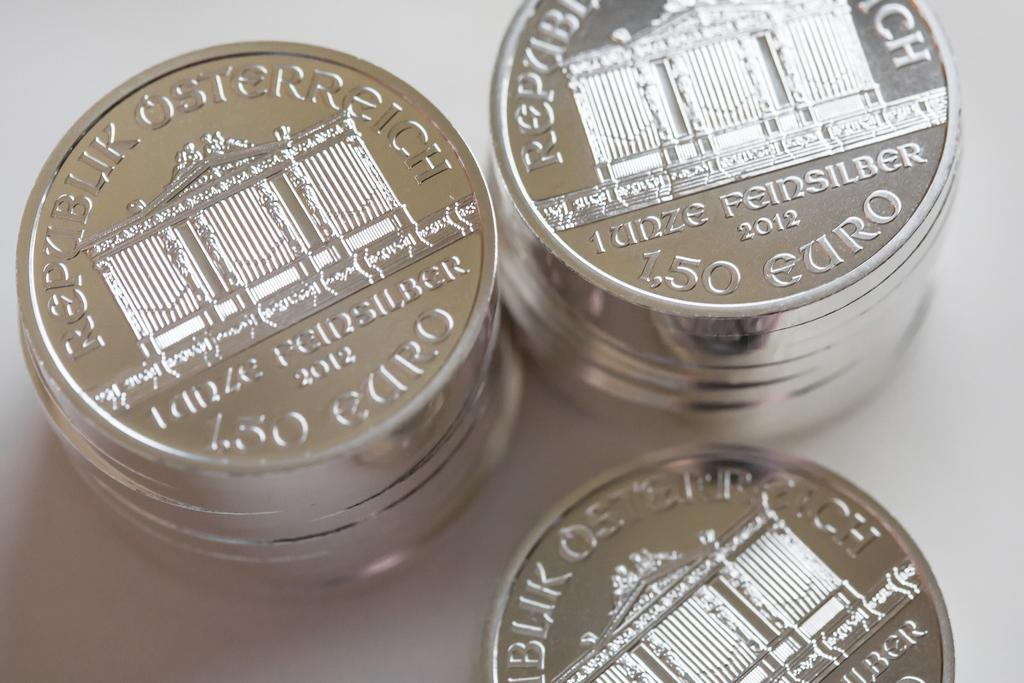Provide a one-sentence caption for the provided image. Three piles of silver Euros depicting the Brandenburg gate and with a value of 1.50. 